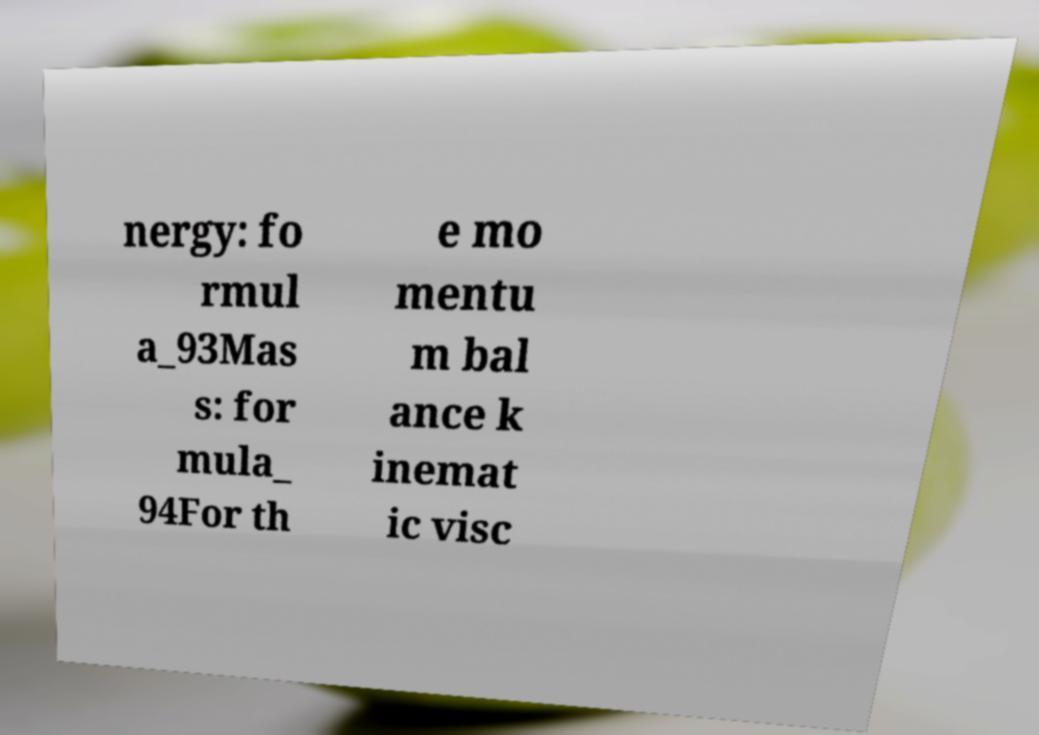Please identify and transcribe the text found in this image. nergy: fo rmul a_93Mas s: for mula_ 94For th e mo mentu m bal ance k inemat ic visc 